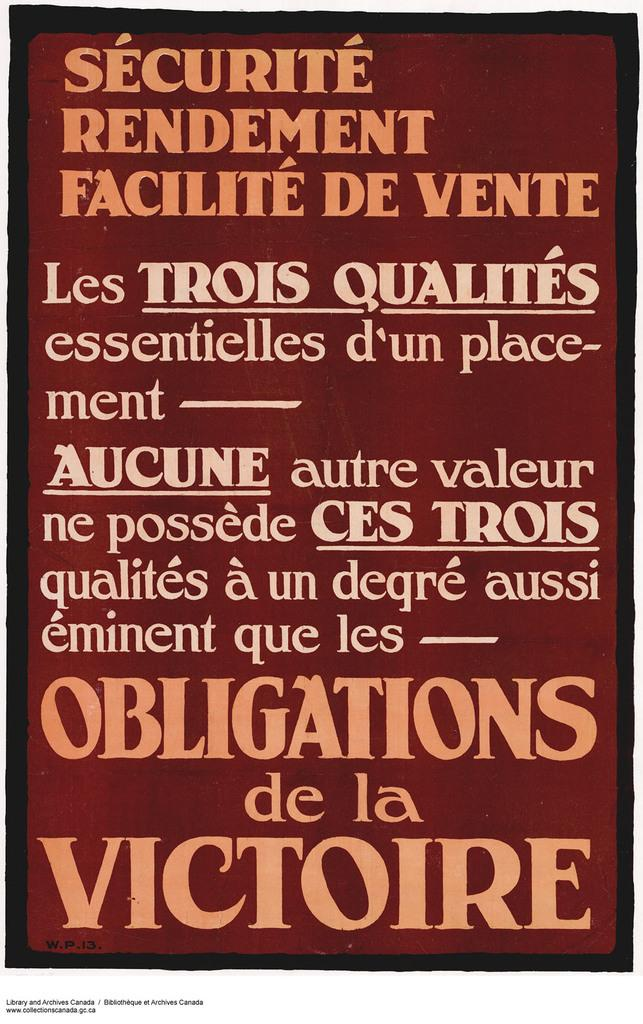<image>
Relay a brief, clear account of the picture shown. A sign written out in french, with big letters saying Obligations de la Victoire 